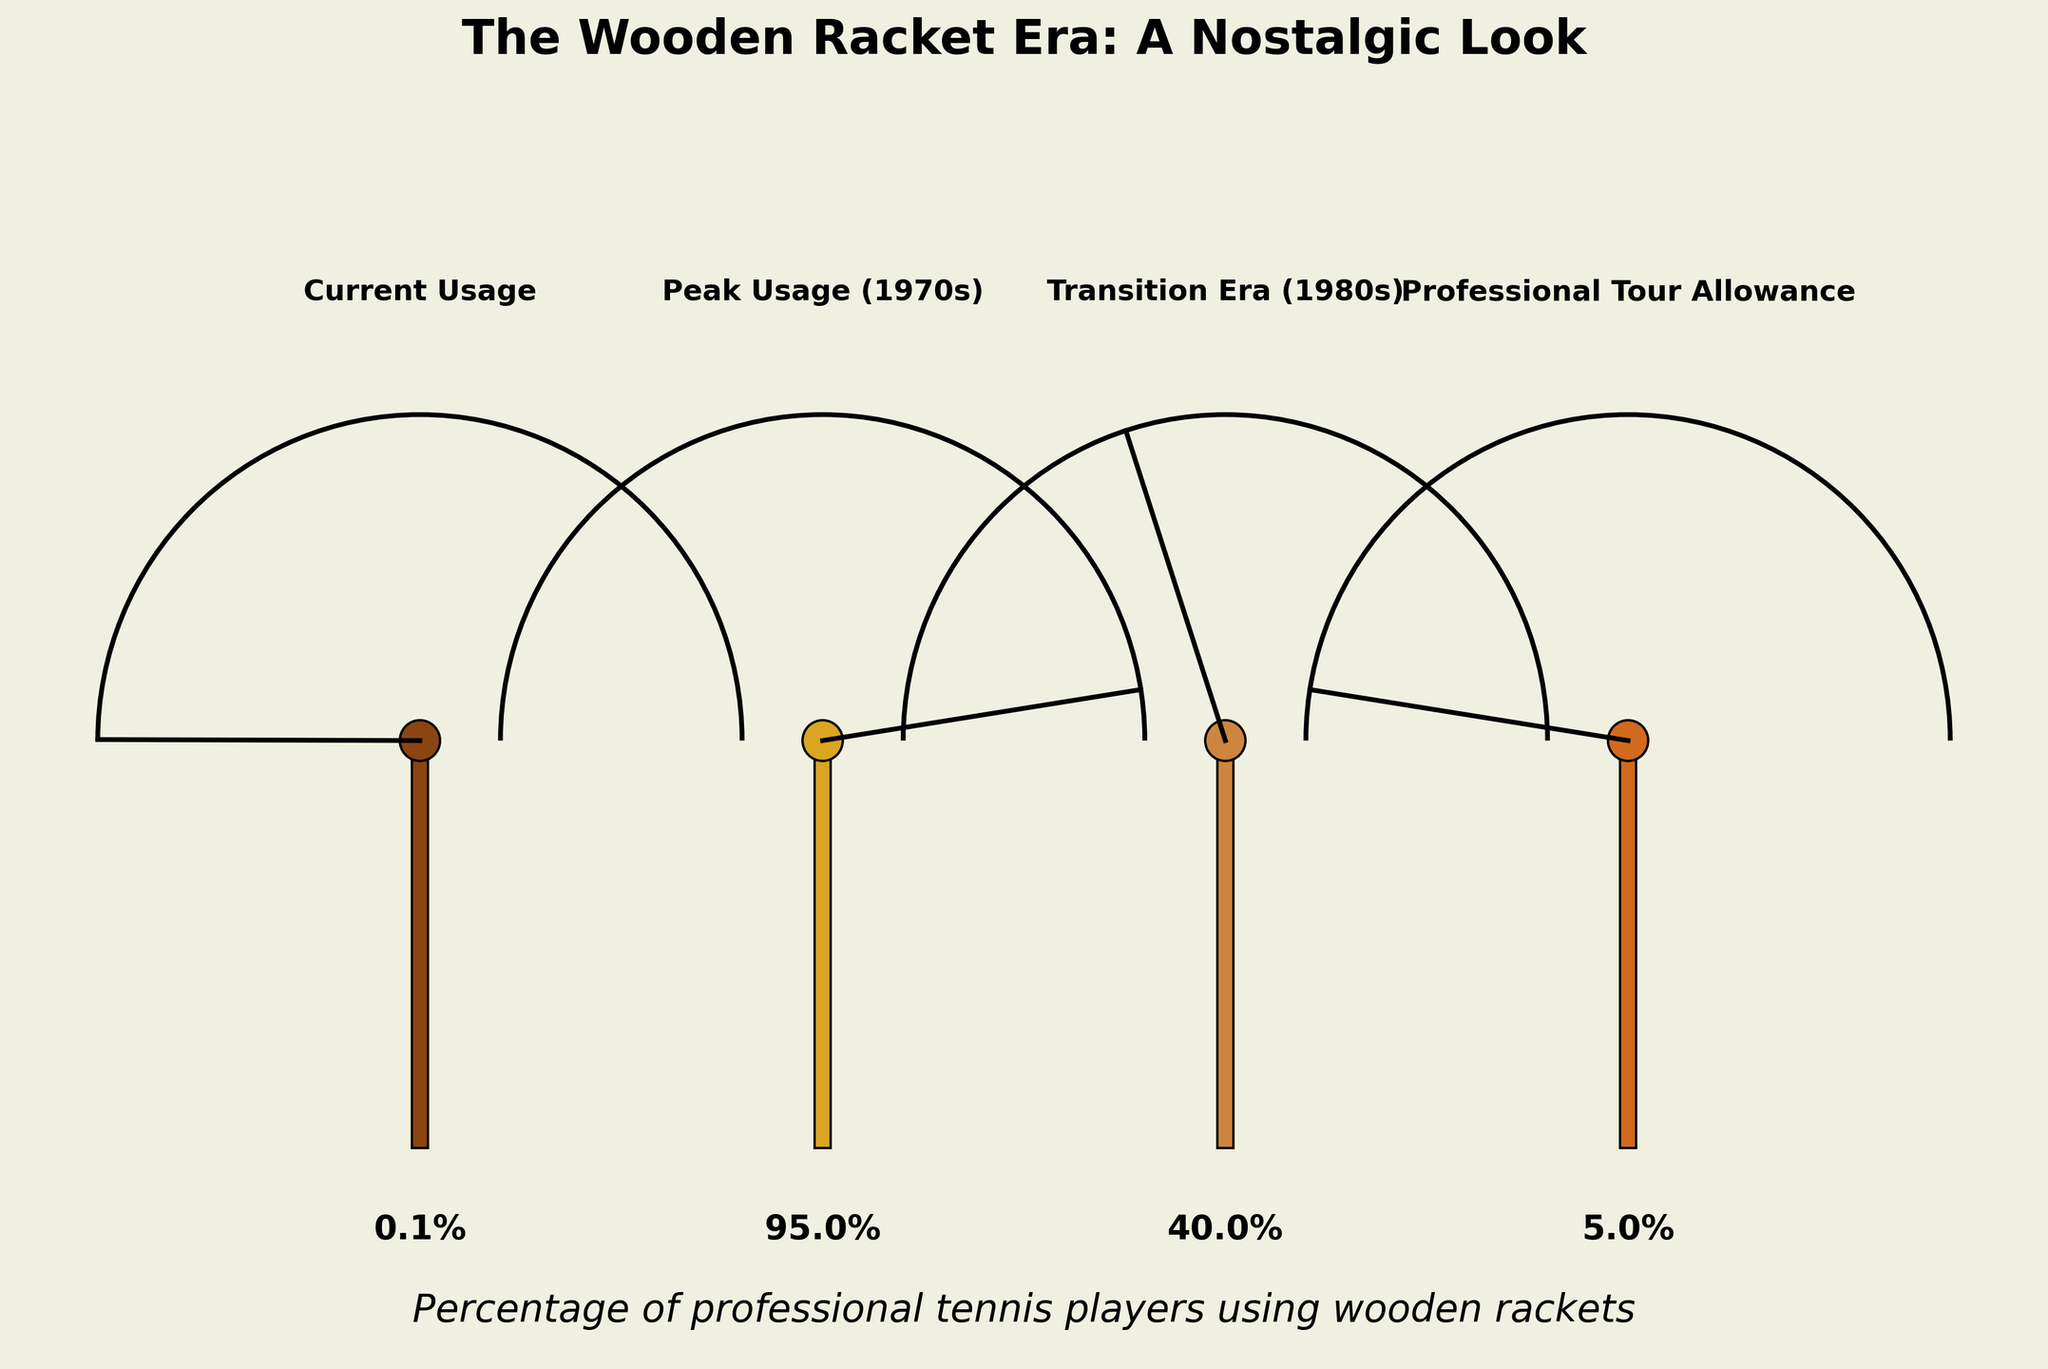What is the percentage of current professional players using wooden rackets? According to the gauge labeled "Current Usage" on the left-most side, the percentage is shown.
Answer: 0.1% What is the title of the plot? The title is positioned at the top center of the plot.
Answer: The Wooden Racket Era: A Nostalgic Look How does the peak usage of wooden rackets in the 1970s compare to the Transition Era in the 1980s? The gauge labeled "Peak Usage (1970s)" shows 95%, while the gauge labeled "Transition Era (1980s)" shows 40%. Subtracting these values gives the difference.
Answer: 55% What is the average percentage usage of wooden rackets across all categories? Add up all the percentages (0.1 + 95 + 40 + 5) and then divide by the number of categories (4).
Answer: 35.025% Which era had the lowest percentage of players using wooden rackets? By comparing all the gauges, the "Professional Tour Allowance" has the lowest value at 5%.
Answer: Professional Tour Allowance Is the current usage of wooden rackets among professional players higher or lower than the professional tour allowance? Comparing the gauge values for "Current Usage" (0.1%) and "Professional Tour Allowance" (5%) shows that the current usage is lower.
Answer: Lower What is the difference between the current usage and the professional tour allowance? Subtract the current usage (0.1%) from the professional tour allowance (5%).
Answer: 4.9% How much did the usage of wooden rackets drop from its peak (1970s) to the current usage? Subtract the current usage (0.1%) from the peak usage (95%).
Answer: 94.9% Given the information in the plot, how would you describe the trend over time concerning the usage of wooden rackets in professional tennis? The gauges show a very high usage during the peak period (95%), a significant drop in the transition era (40%), further reduction in the professional tour allowance period (5%), and almost no usage in the current era (0.1%).
Answer: Decreasing trend 